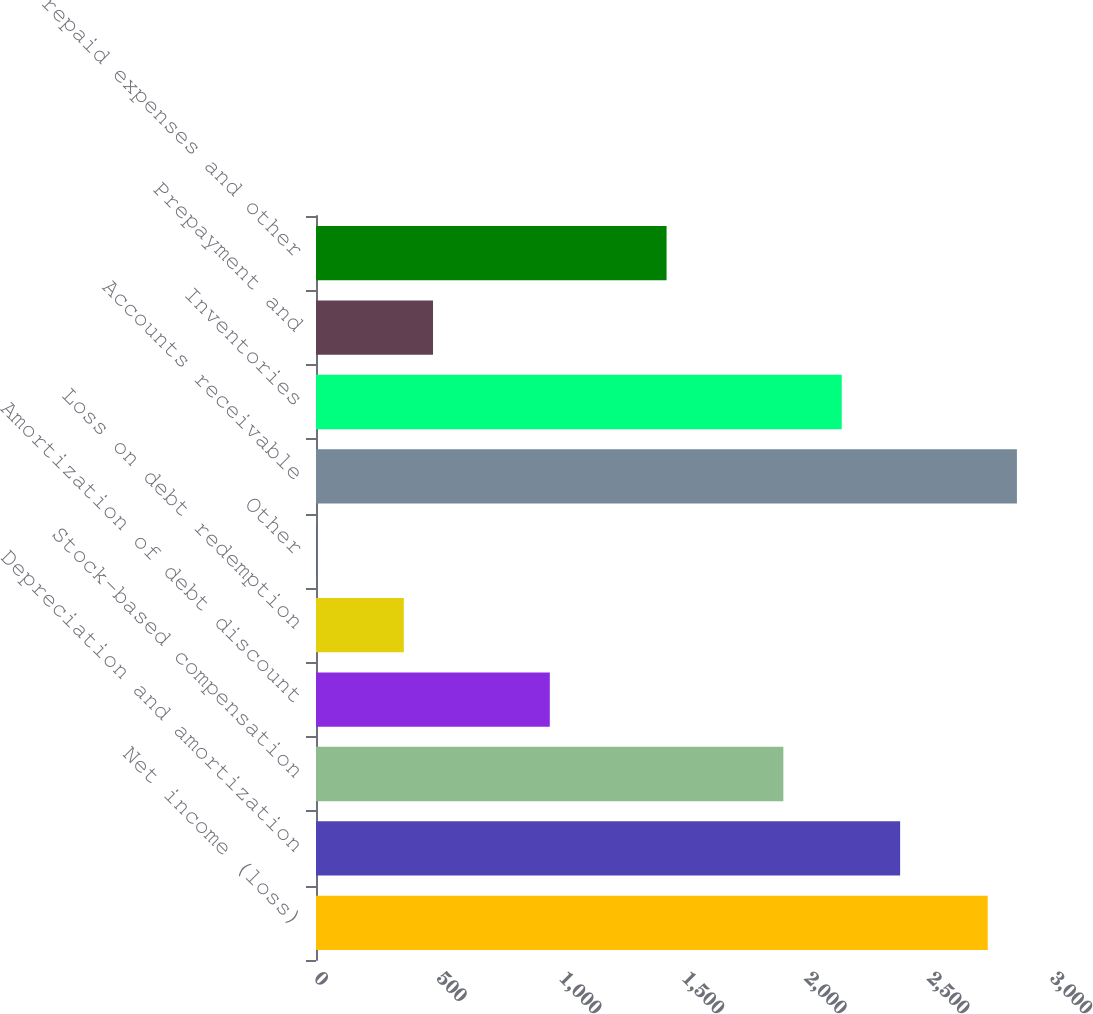<chart> <loc_0><loc_0><loc_500><loc_500><bar_chart><fcel>Net income (loss)<fcel>Depreciation and amortization<fcel>Stock-based compensation<fcel>Amortization of debt discount<fcel>Loss on debt redemption<fcel>Other<fcel>Accounts receivable<fcel>Inventories<fcel>Prepayment and<fcel>Prepaid expenses and other<nl><fcel>2738<fcel>2381<fcel>1905<fcel>953<fcel>358<fcel>1<fcel>2857<fcel>2143<fcel>477<fcel>1429<nl></chart> 